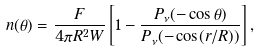Convert formula to latex. <formula><loc_0><loc_0><loc_500><loc_500>n ( \theta ) = \frac { F } { 4 \pi R ^ { 2 } W } \left [ 1 - \frac { P _ { \nu } ( - \cos \theta ) } { P _ { \nu } ( - \cos ( r / R ) ) } \right ] ,</formula> 